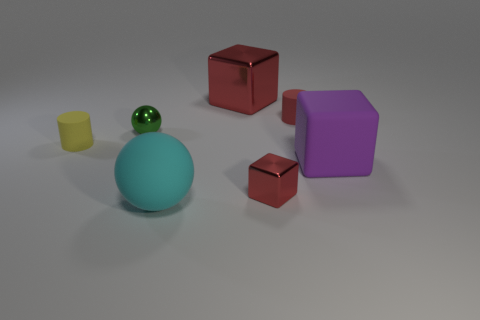Which is the largest object and which is the smallest? The largest object in the image is the blue sphere, while the smallest one appears to be the tiny yellow cylinder. 